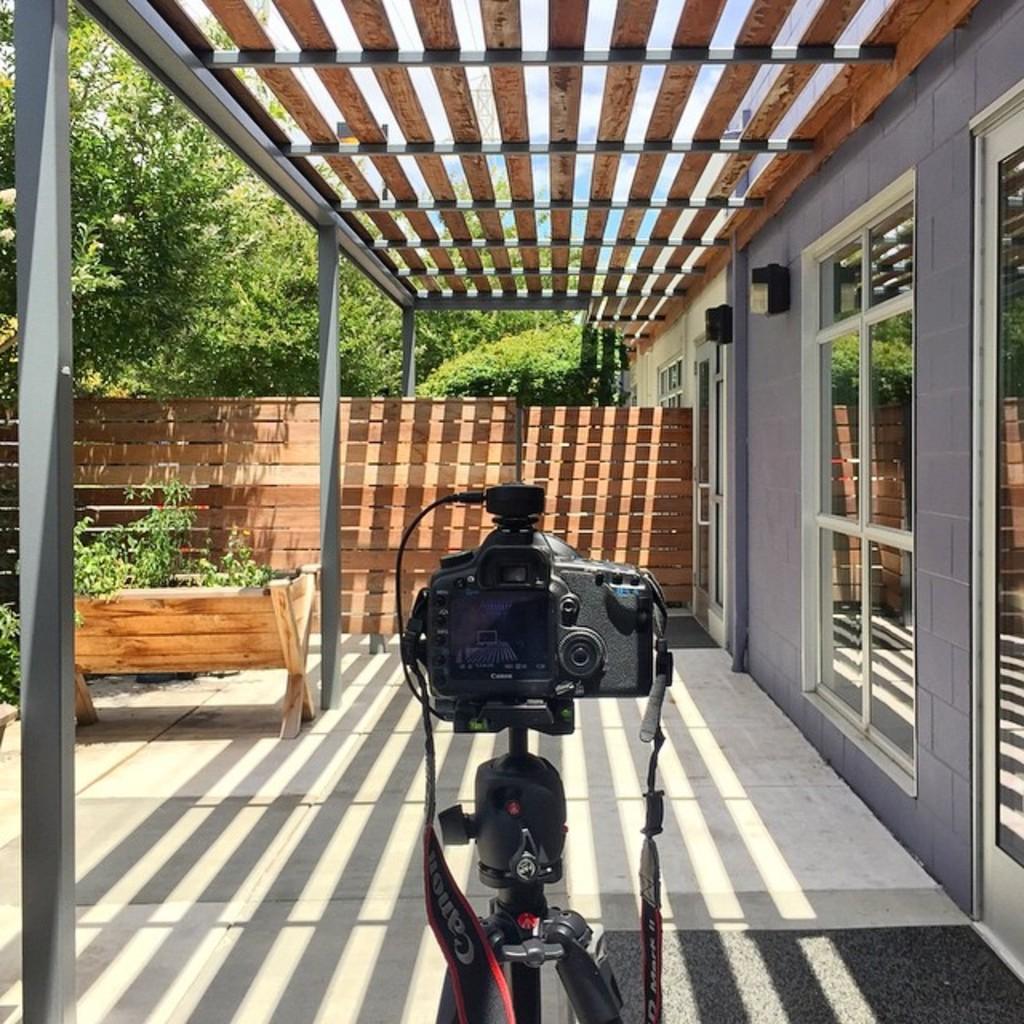How would you summarize this image in a sentence or two? There is a camera placed on a stand and there is a wooden wall and trees in front of it. 